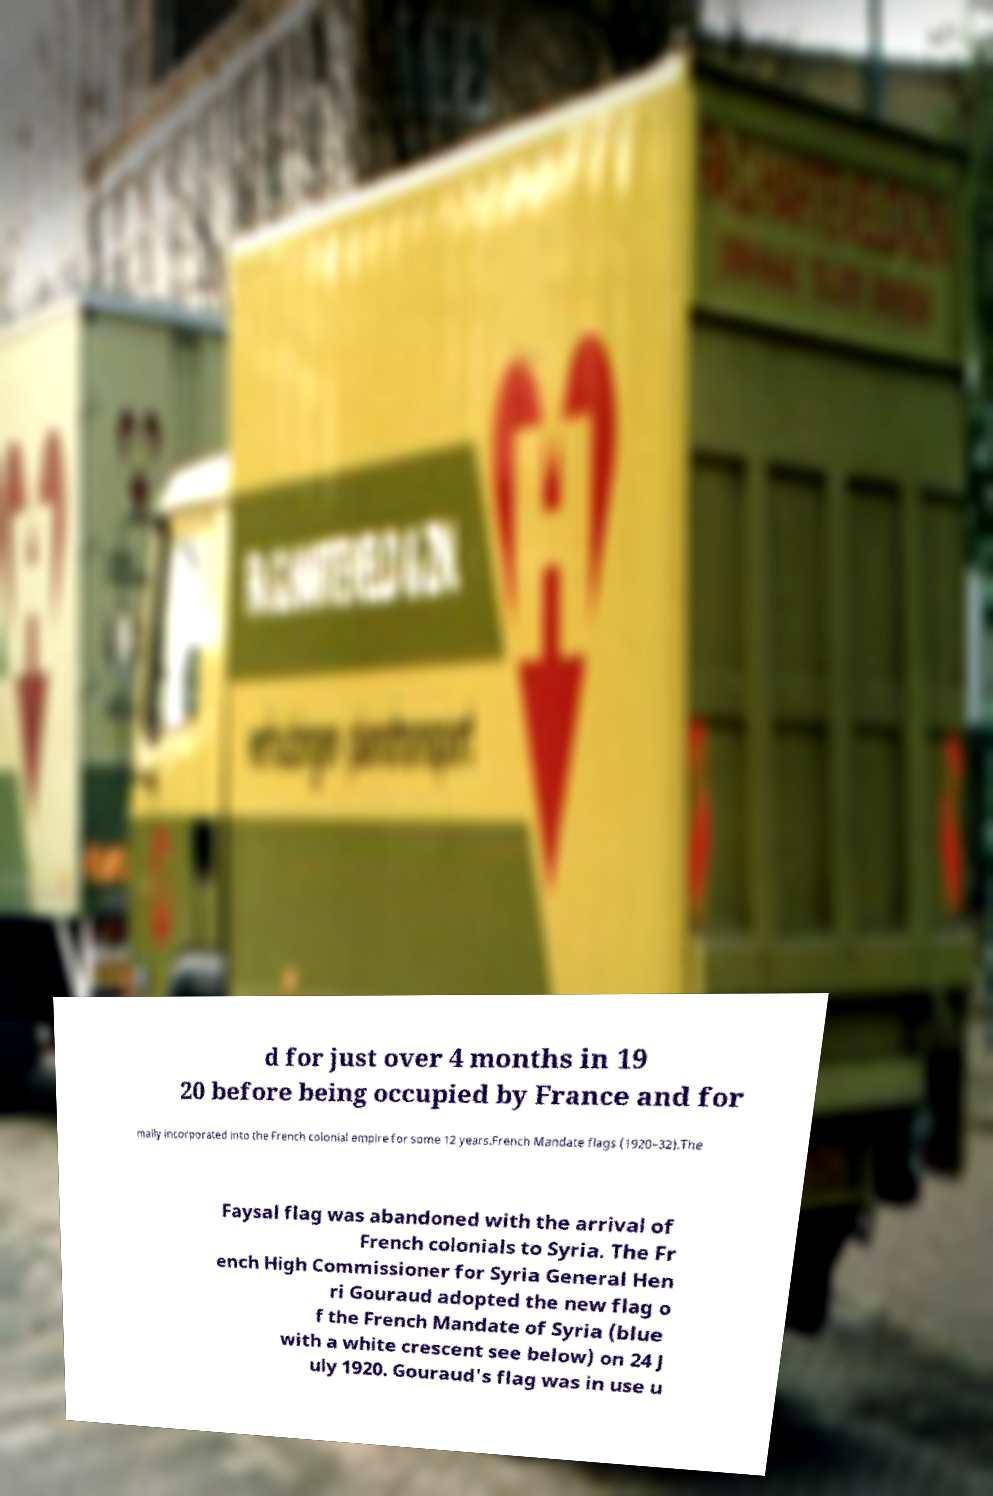Can you read and provide the text displayed in the image?This photo seems to have some interesting text. Can you extract and type it out for me? d for just over 4 months in 19 20 before being occupied by France and for mally incorporated into the French colonial empire for some 12 years.French Mandate flags (1920–32).The Faysal flag was abandoned with the arrival of French colonials to Syria. The Fr ench High Commissioner for Syria General Hen ri Gouraud adopted the new flag o f the French Mandate of Syria (blue with a white crescent see below) on 24 J uly 1920. Gouraud's flag was in use u 